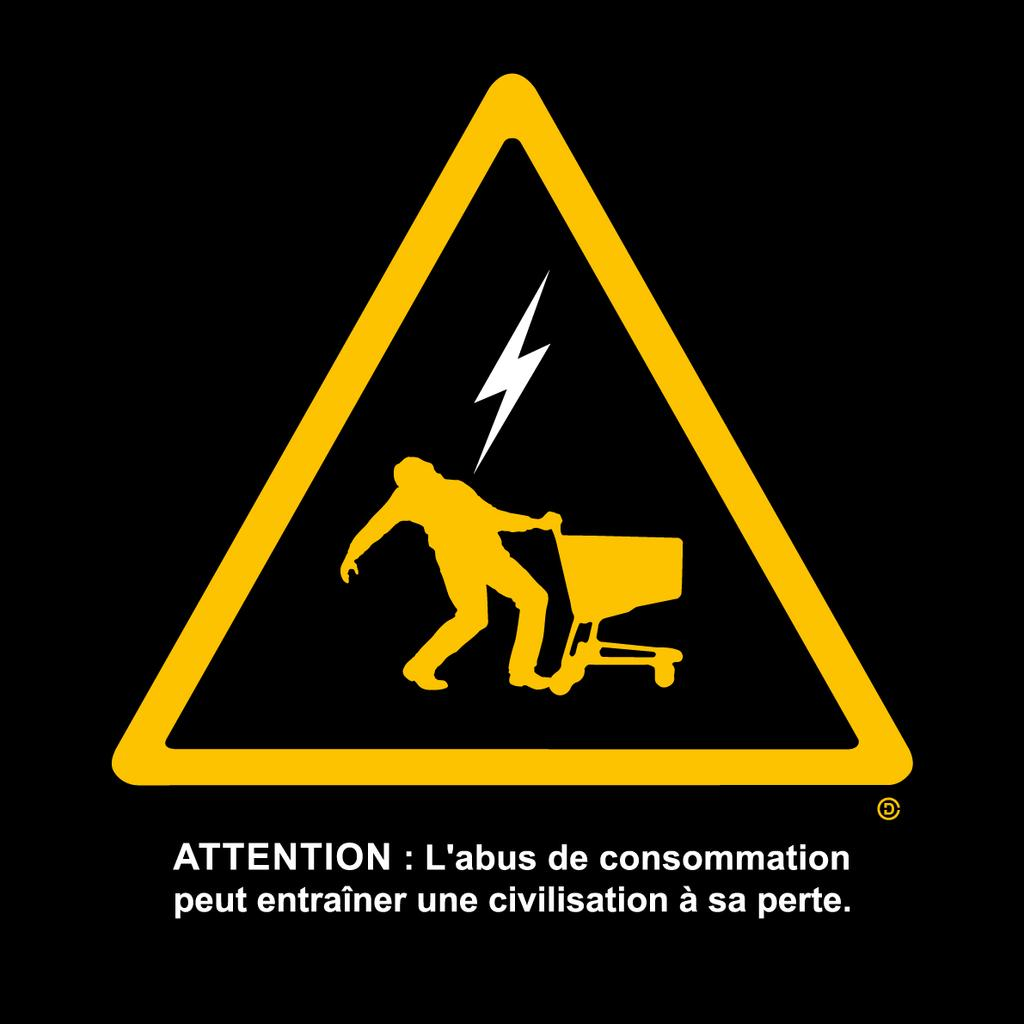<image>
Summarize the visual content of the image. A picture of someone getting electrocuted while holding a shopping cart with the caption Attention. 